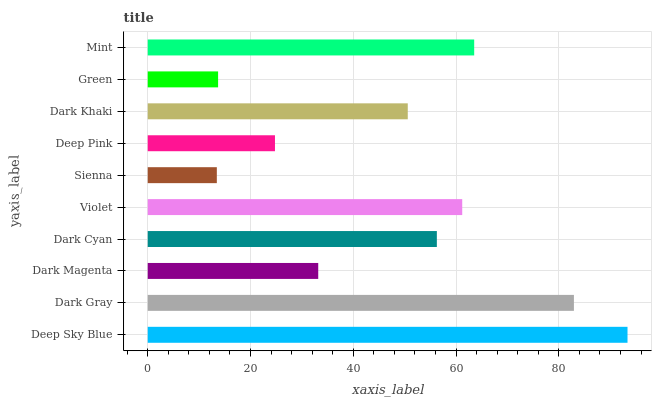Is Sienna the minimum?
Answer yes or no. Yes. Is Deep Sky Blue the maximum?
Answer yes or no. Yes. Is Dark Gray the minimum?
Answer yes or no. No. Is Dark Gray the maximum?
Answer yes or no. No. Is Deep Sky Blue greater than Dark Gray?
Answer yes or no. Yes. Is Dark Gray less than Deep Sky Blue?
Answer yes or no. Yes. Is Dark Gray greater than Deep Sky Blue?
Answer yes or no. No. Is Deep Sky Blue less than Dark Gray?
Answer yes or no. No. Is Dark Cyan the high median?
Answer yes or no. Yes. Is Dark Khaki the low median?
Answer yes or no. Yes. Is Dark Magenta the high median?
Answer yes or no. No. Is Deep Sky Blue the low median?
Answer yes or no. No. 